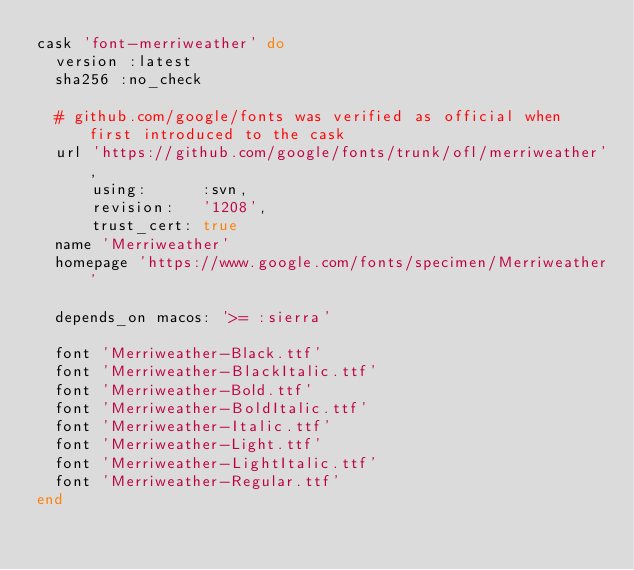Convert code to text. <code><loc_0><loc_0><loc_500><loc_500><_Ruby_>cask 'font-merriweather' do
  version :latest
  sha256 :no_check

  # github.com/google/fonts was verified as official when first introduced to the cask
  url 'https://github.com/google/fonts/trunk/ofl/merriweather',
      using:      :svn,
      revision:   '1208',
      trust_cert: true
  name 'Merriweather'
  homepage 'https://www.google.com/fonts/specimen/Merriweather'

  depends_on macos: '>= :sierra'

  font 'Merriweather-Black.ttf'
  font 'Merriweather-BlackItalic.ttf'
  font 'Merriweather-Bold.ttf'
  font 'Merriweather-BoldItalic.ttf'
  font 'Merriweather-Italic.ttf'
  font 'Merriweather-Light.ttf'
  font 'Merriweather-LightItalic.ttf'
  font 'Merriweather-Regular.ttf'
end
</code> 